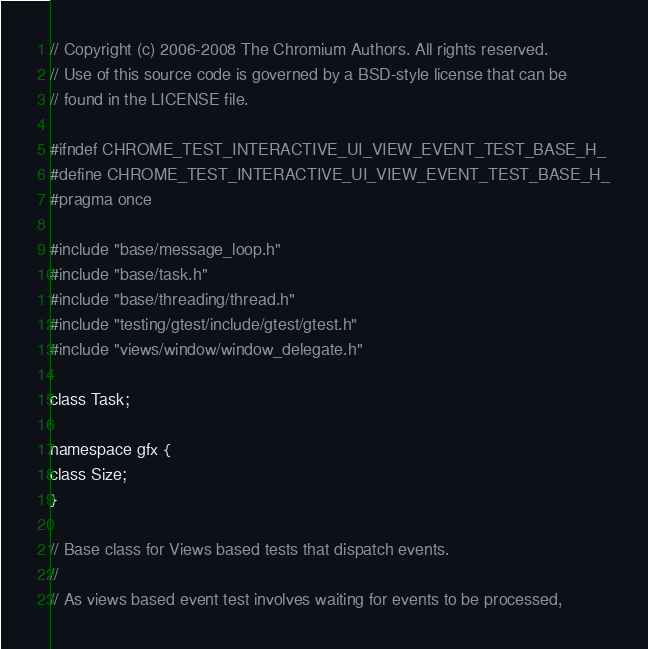<code> <loc_0><loc_0><loc_500><loc_500><_C_>// Copyright (c) 2006-2008 The Chromium Authors. All rights reserved.
// Use of this source code is governed by a BSD-style license that can be
// found in the LICENSE file.

#ifndef CHROME_TEST_INTERACTIVE_UI_VIEW_EVENT_TEST_BASE_H_
#define CHROME_TEST_INTERACTIVE_UI_VIEW_EVENT_TEST_BASE_H_
#pragma once

#include "base/message_loop.h"
#include "base/task.h"
#include "base/threading/thread.h"
#include "testing/gtest/include/gtest/gtest.h"
#include "views/window/window_delegate.h"

class Task;

namespace gfx {
class Size;
}

// Base class for Views based tests that dispatch events.
//
// As views based event test involves waiting for events to be processed,</code> 